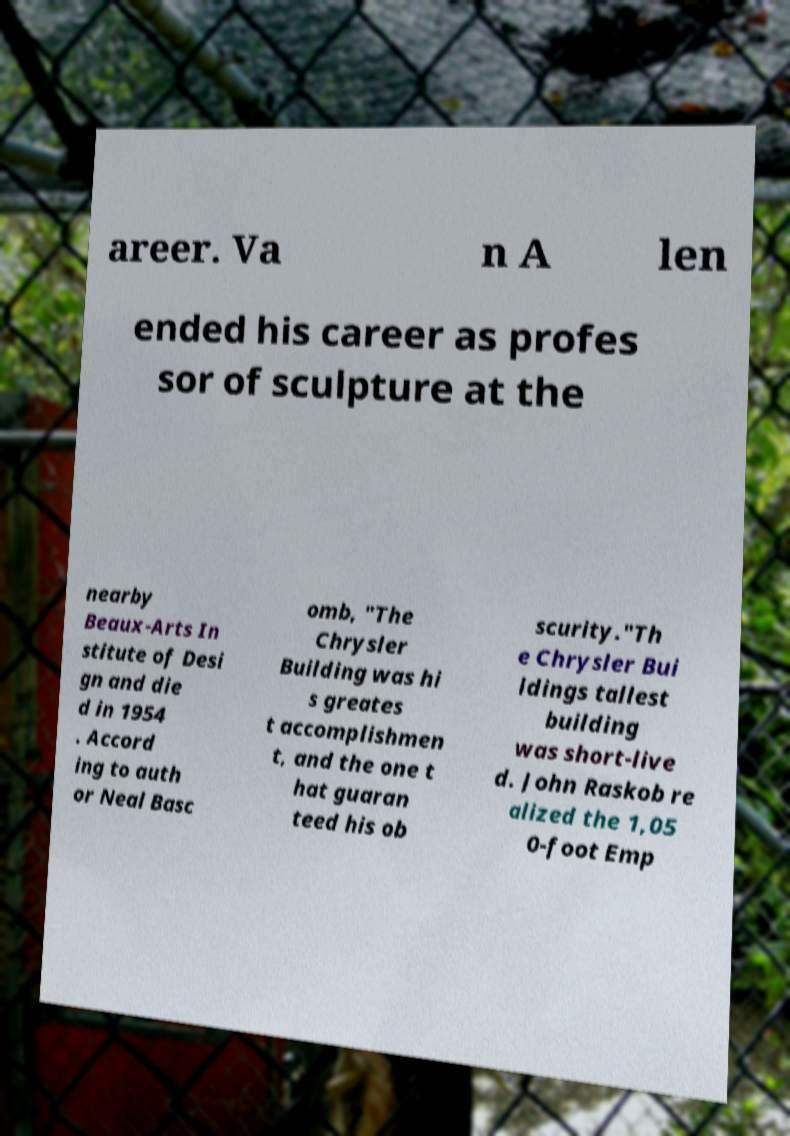Can you read and provide the text displayed in the image?This photo seems to have some interesting text. Can you extract and type it out for me? areer. Va n A len ended his career as profes sor of sculpture at the nearby Beaux-Arts In stitute of Desi gn and die d in 1954 . Accord ing to auth or Neal Basc omb, "The Chrysler Building was hi s greates t accomplishmen t, and the one t hat guaran teed his ob scurity."Th e Chrysler Bui ldings tallest building was short-live d. John Raskob re alized the 1,05 0-foot Emp 